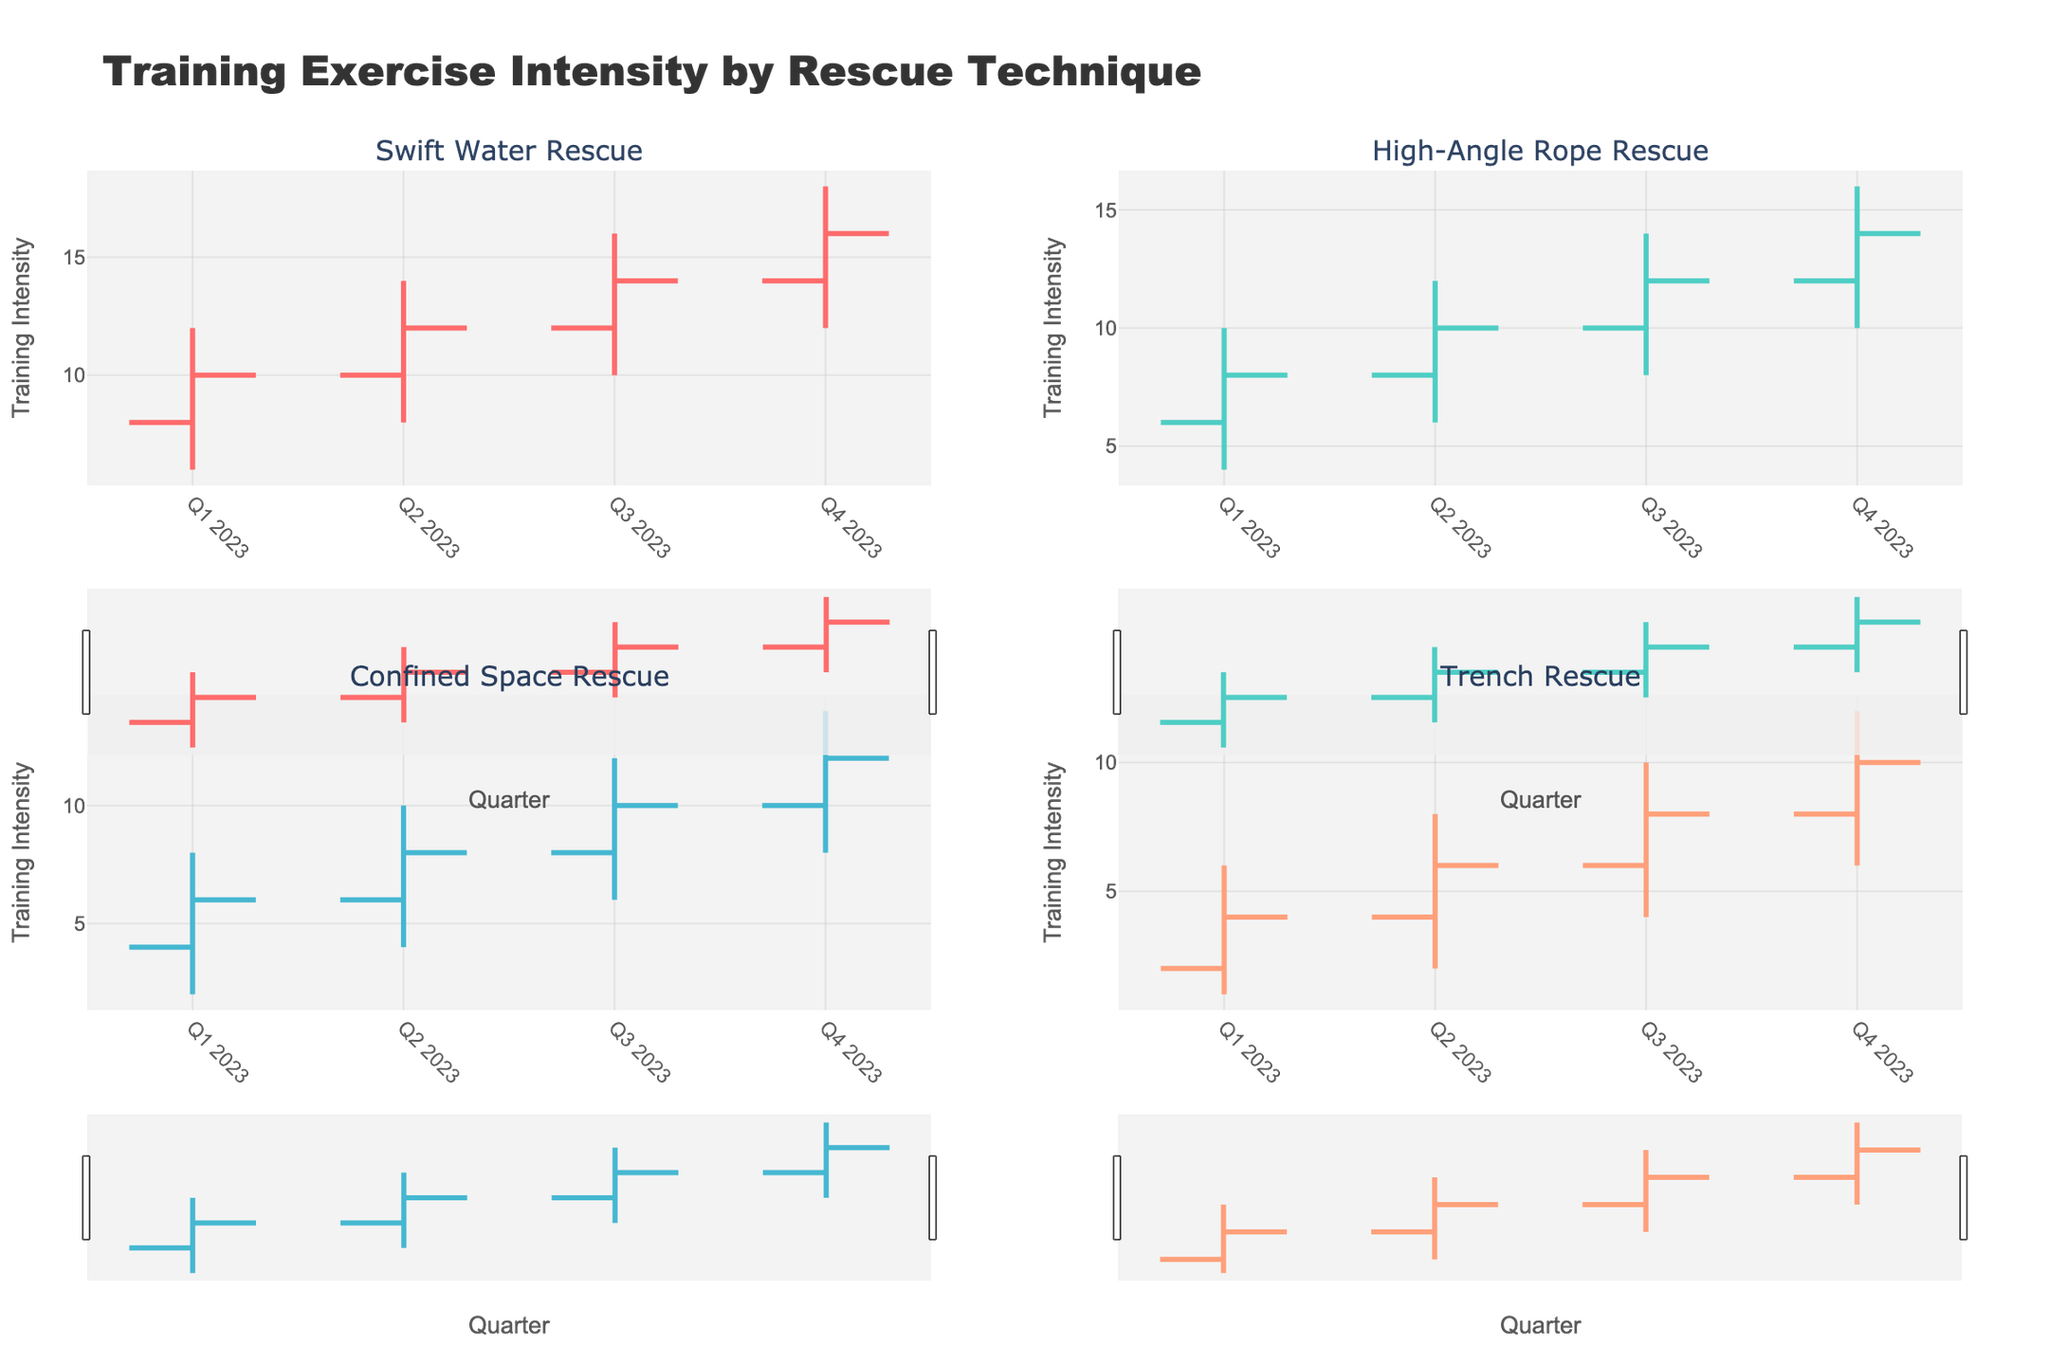What is the title of the chart? The title is displayed at the top of the chart and reads "Training Exercise Intensity by Rescue Technique".
Answer: Training Exercise Intensity by Rescue Technique What are the rescue techniques shown in the chart? The subplot titles list the rescue techniques, which are Swift Water Rescue, High-Angle Rope Rescue, Confined Space Rescue, and Trench Rescue.
Answer: Swift Water Rescue, High-Angle Rope Rescue, Confined Space Rescue, Trench Rescue In which quarter did Swift Water Rescue have its highest training intensity? Observing the 'High' values for Swift Water Rescue, the highest training intensity is 18 and occurs in Q4 2023.
Answer: Q4 2023 How does the training intensity for High-Angle Rope Rescue change from Q1 2023 to Q2 2023? Compare the 'Open' and 'Close' values from Q1 2023 (6 opening to 8 closing) to Q2 2023 (8 opening to 10 closing). It shows an increase of 2 in each quarter.
Answer: Increase What is the average 'Close' value for Confined Space Rescue over the four quarters? The 'Close' values for Confined Space Rescue over four quarters are 6, 8, 10, and 12. Summing these gives 36, and dividing by 4 gives the average. 36 / 4 = 9
Answer: 9 Which rescue technique had the highest 'Low' value in Q3 2023? Compare the 'Low' values in Q3 2023 across all techniques: Swift Water Rescue (10), High-Angle Rope Rescue (8), Confined Space Rescue (6), and Trench Rescue (4). The highest value is for Swift Water Rescue.
Answer: Swift Water Rescue What is the difference in 'High' values between Swift Water Rescue and Trench Rescue in Q4 2023? The 'High' value for Swift Water Rescue in Q4 2023 is 18 and for Trench Rescue it is 12. The difference is 18 - 12 = 6.
Answer: 6 Did any technique show a decrease in training intensity ('Open' to 'Close') in any quarter? Review the 'Open' to 'Close' values for each technique in all quarters. All values show an increase or no change.
Answer: No What is the total sum of 'Open' values for Trench Rescue over all quarters? The 'Open' values for Trench Rescue over the four quarters are 2, 4, 6, and 8. The total sum is 2 + 4 + 6 + 8 = 20.
Answer: 20 Which quarter had the highest training intensity (in terms of 'High' values) for all techniques combined? Sum the 'High' values across all techniques for each quarter: Q1 2023 (12 + 10 + 8 + 6 = 36), Q2 2023 (14 + 12 + 10 + 8 = 44), Q3 2023 (16 + 14 + 12 + 10 = 52), Q4 2023 (18 + 16 + 14 + 12 = 60). The highest total is for Q4 2023.
Answer: Q4 2023 